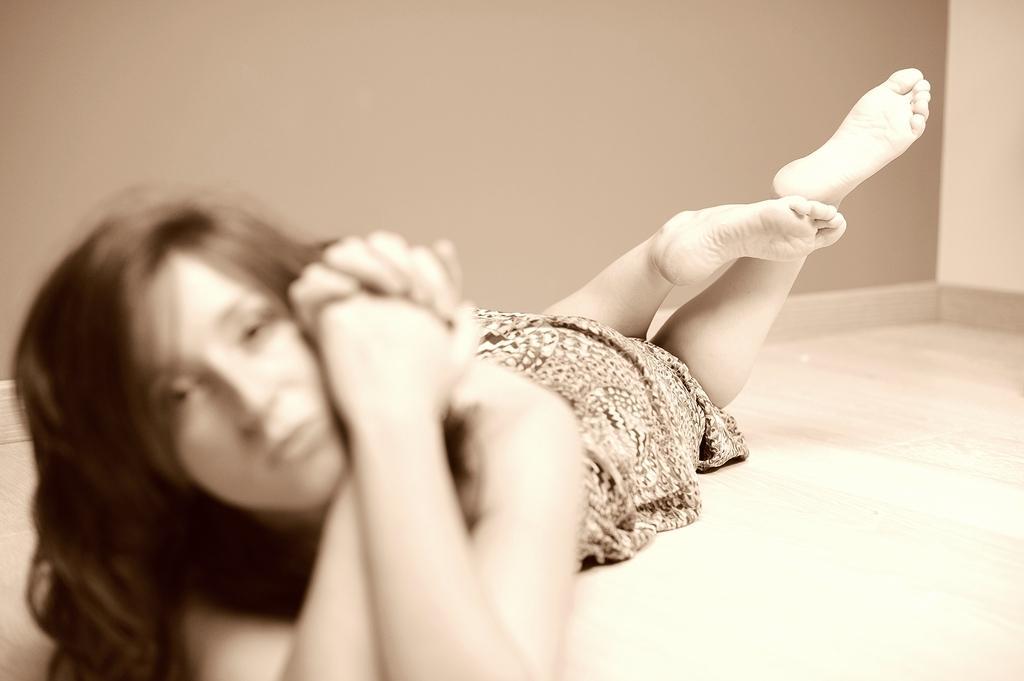Describe this image in one or two sentences. In this image there is a woman lying on the floor, there is a wall towards the top of the image. 